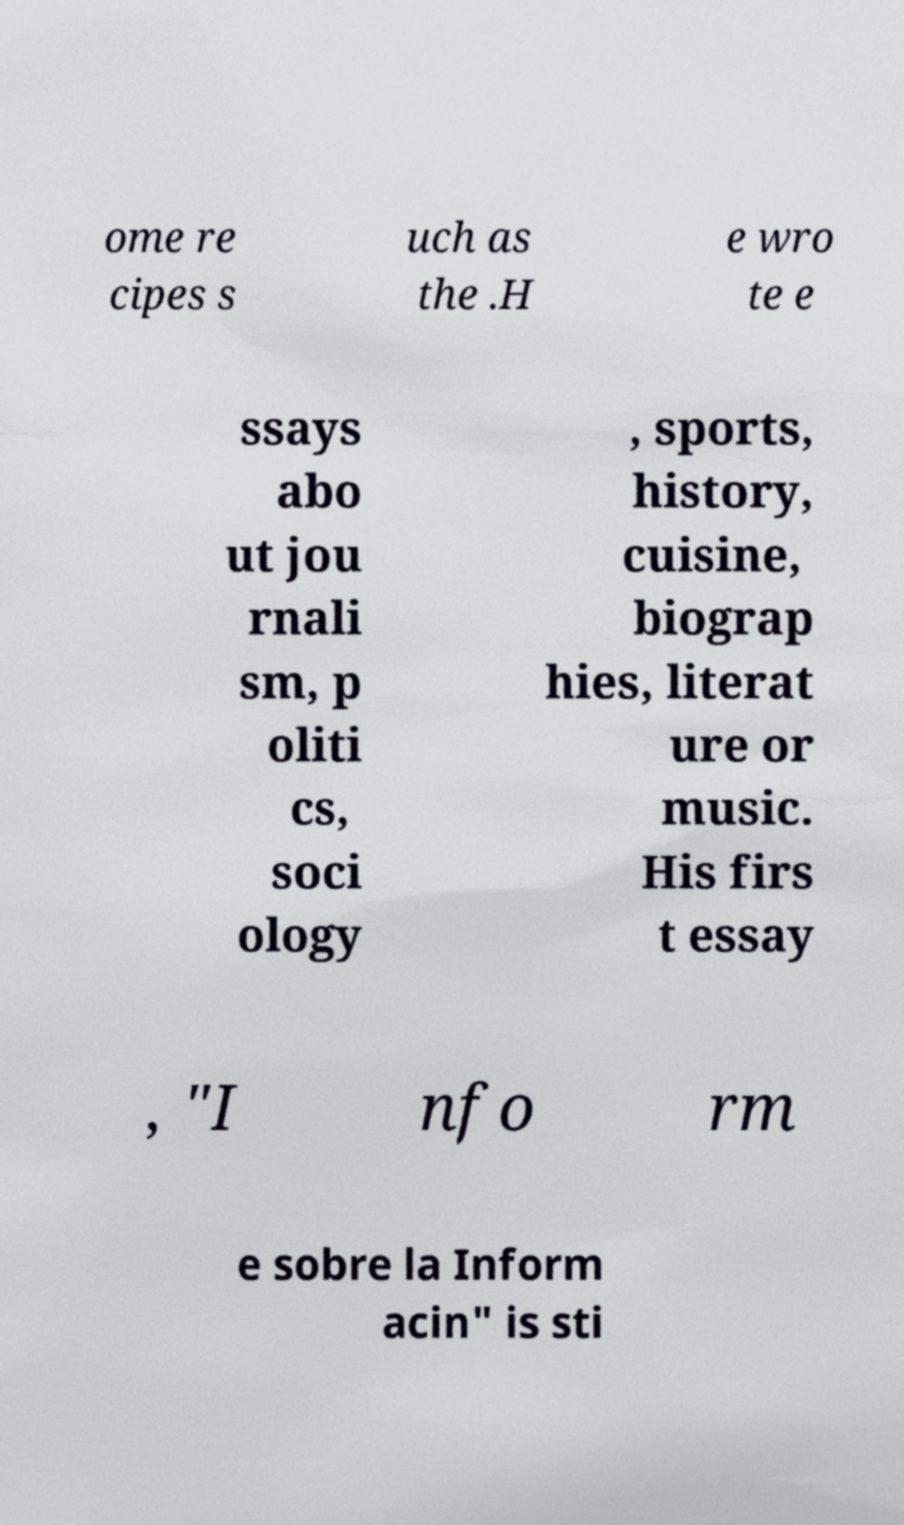Please identify and transcribe the text found in this image. ome re cipes s uch as the .H e wro te e ssays abo ut jou rnali sm, p oliti cs, soci ology , sports, history, cuisine, biograp hies, literat ure or music. His firs t essay , "I nfo rm e sobre la Inform acin" is sti 